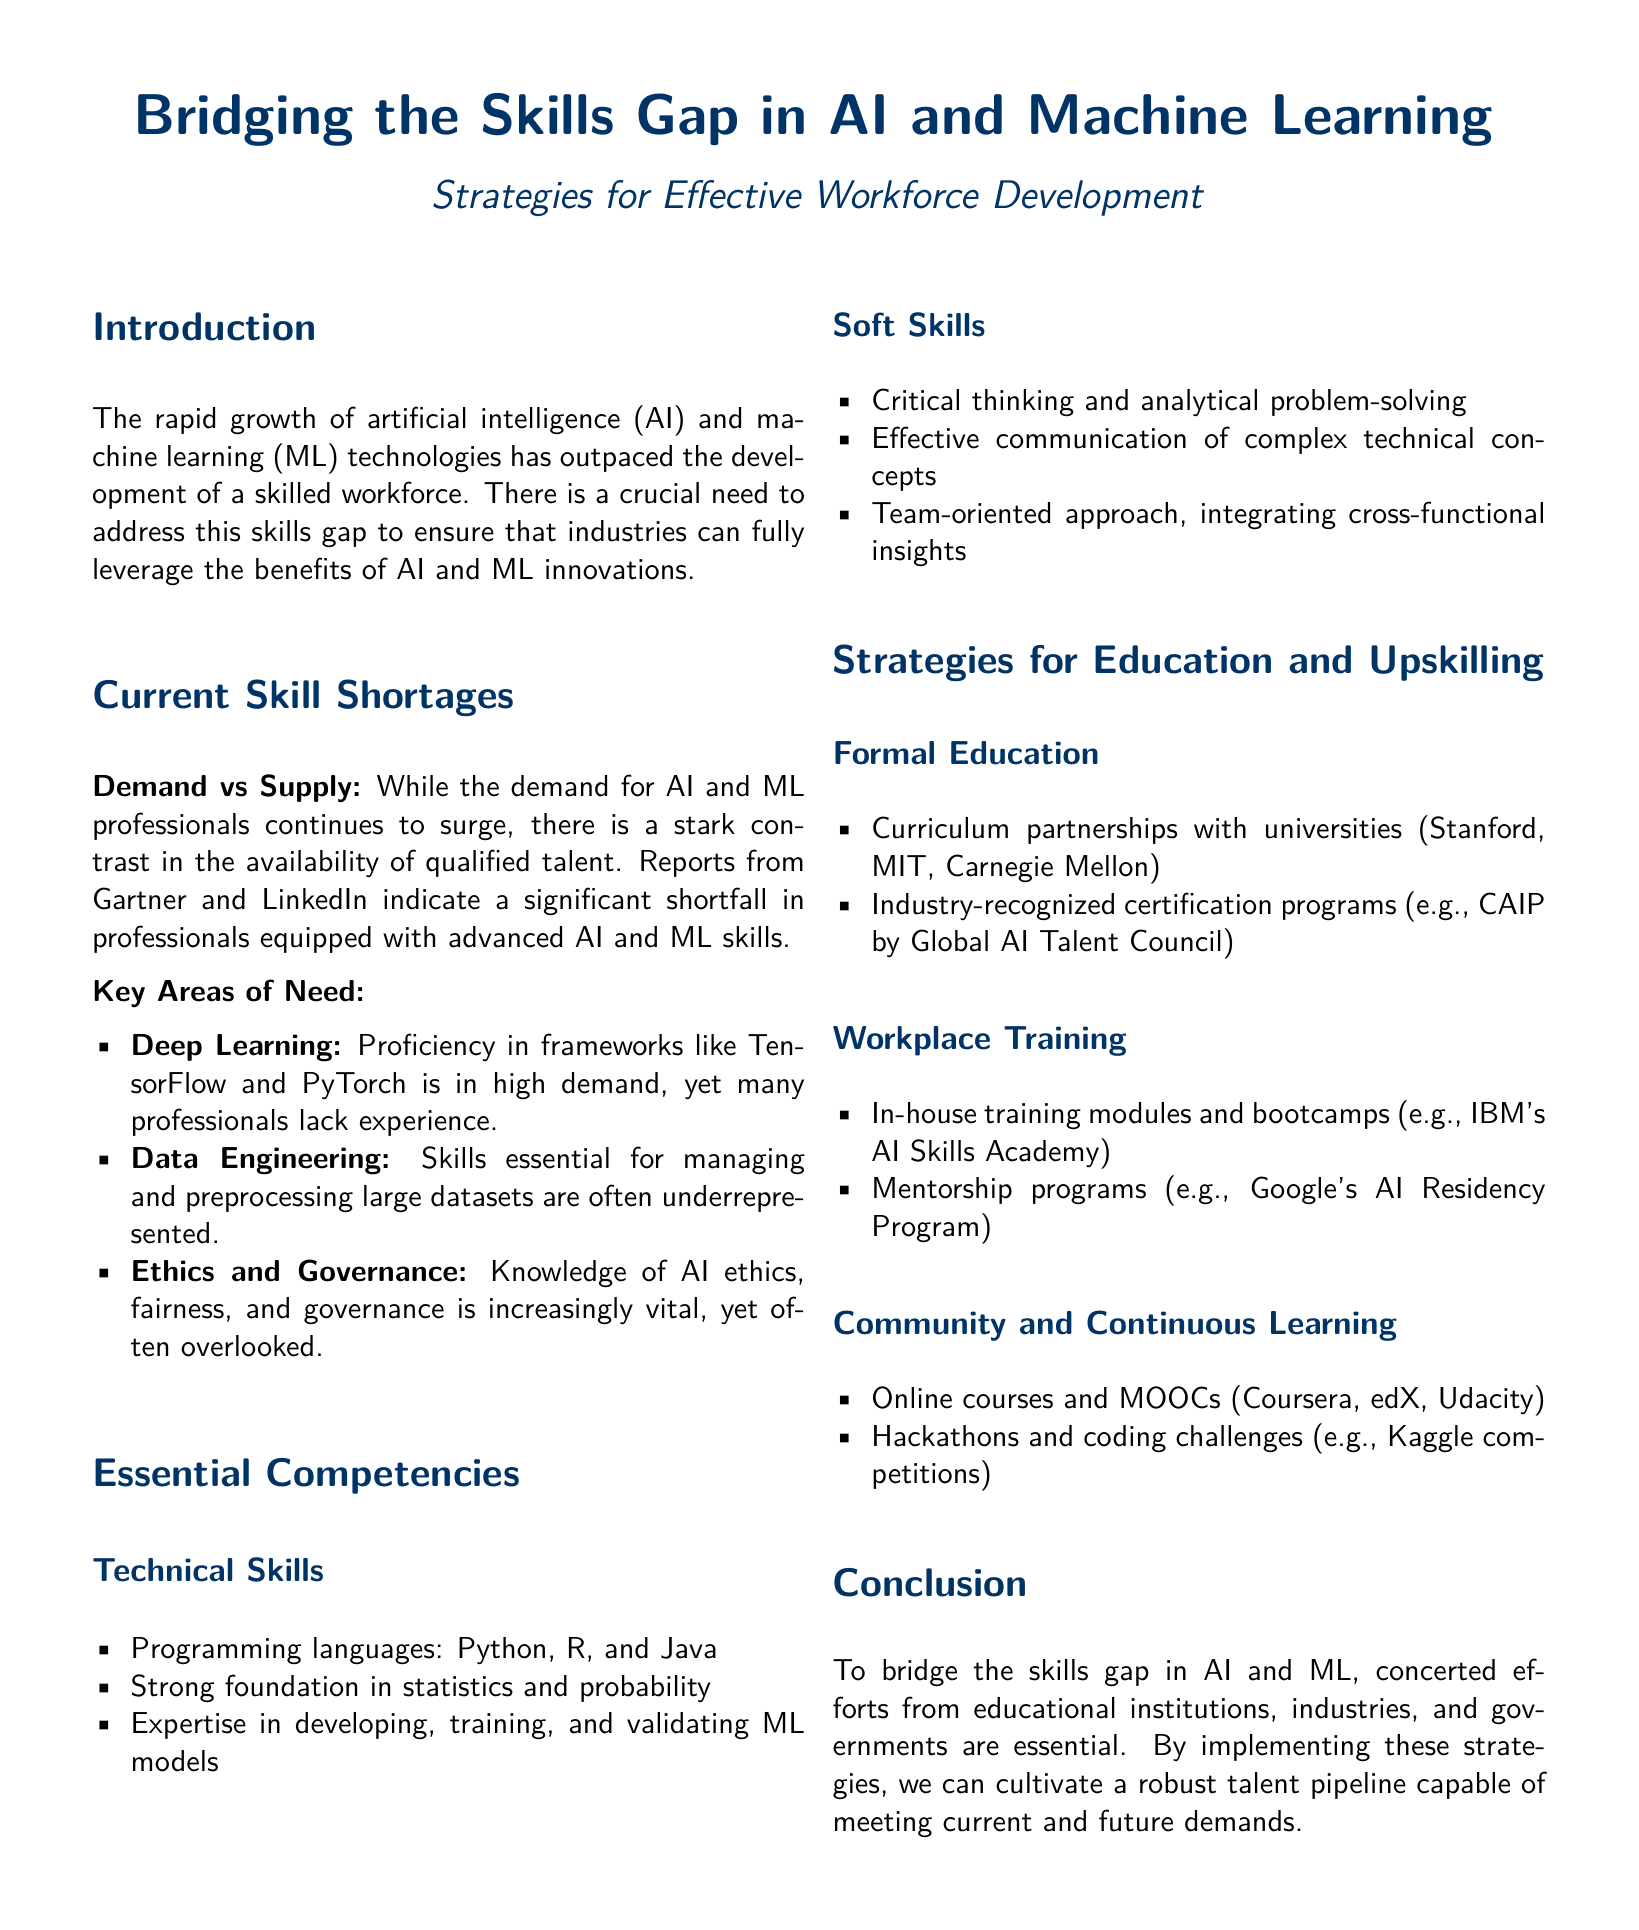What is the focus of the whitepaper? The whitepaper discusses strategies for workforce development to bridge skill gaps in AI and machine learning.
Answer: Workforce development Which organizations are mentioned for curriculum partnerships? The document lists universities such as Stanford, MIT, and Carnegie Mellon for curriculum partnerships.
Answer: Stanford, MIT, Carnegie Mellon What is an essential technical skill mentioned? The document states that expertise in developing, training, and validating ML models is an essential technical skill.
Answer: ML models What is one of the key areas of skill need? The whitepaper identifies deep learning as a key area where skills are needed.
Answer: Deep Learning Name a program mentioned for workplace training. The Google AI Residency Program is mentioned as a mentorship program for workplace training.
Answer: Google AI Residency Program What percentage of professionals lack experience in deep learning? The document does not specify a percentage, but it notes that many professionals lack experience in deep learning.
Answer: Not specified What type of programs are suggested for continuous learning? Online courses and MOOCs are suggested programs for continuous learning.
Answer: Online courses and MOOCs What demographic is crucial for bridging the skills gap? The document emphasizes the need for a skilled workforce as crucial for bridging the skills gap.
Answer: Skilled workforce What color is used for section headings in the document? The document uses a deep blue color for section headings.
Answer: Deep blue 